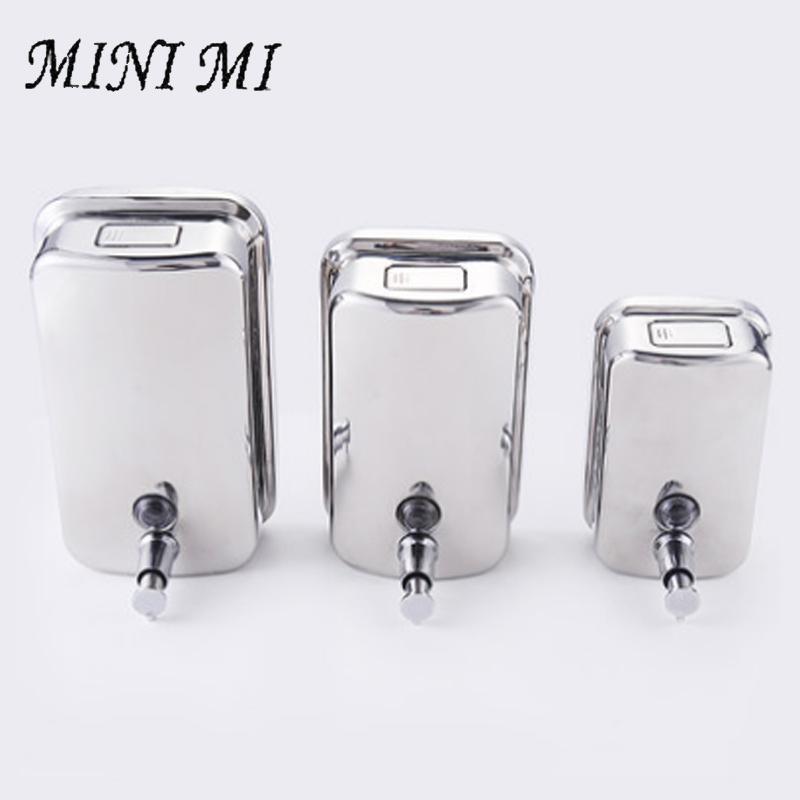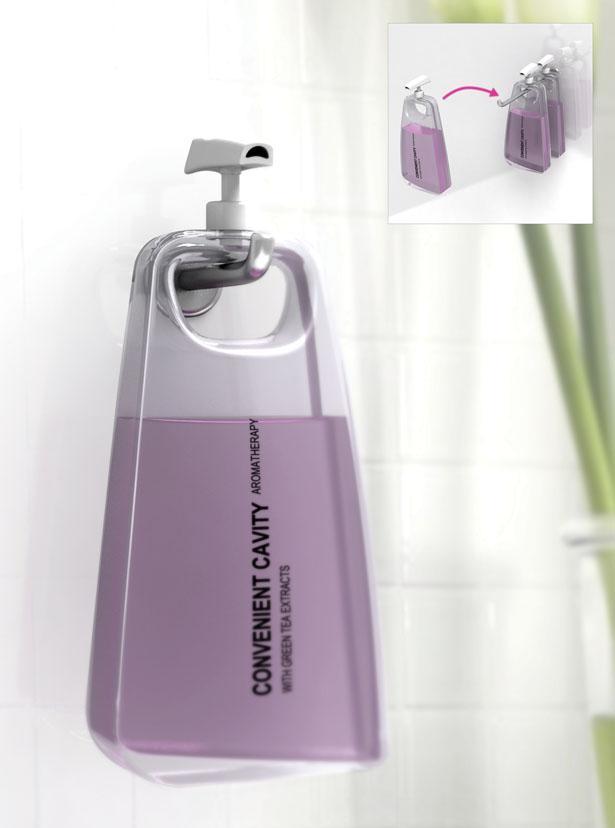The first image is the image on the left, the second image is the image on the right. For the images shown, is this caption "A person is getting soap from a dispenser in the image on the right." true? Answer yes or no. No. The first image is the image on the left, the second image is the image on the right. Examine the images to the left and right. Is the description "There are exactly four dispensers, and at least of them are chrome." accurate? Answer yes or no. Yes. 